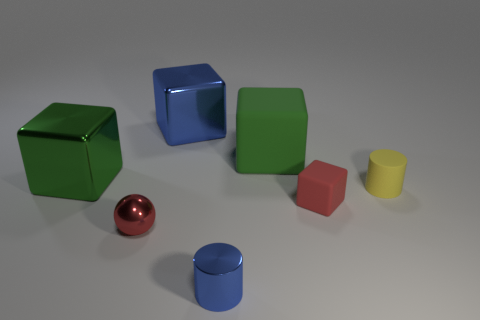There is a small cylinder on the right side of the matte thing behind the large shiny block that is to the left of the big blue block; what is it made of?
Ensure brevity in your answer.  Rubber. Does the shiny cylinder have the same color as the big metal object that is behind the green shiny thing?
Your answer should be very brief. Yes. What number of things are either matte things to the right of the green matte cube or metal things behind the tiny red matte cube?
Your answer should be compact. 4. The blue thing behind the metal block that is on the left side of the red metallic ball is what shape?
Make the answer very short. Cube. Is there a cylinder made of the same material as the red ball?
Your answer should be compact. Yes. The tiny object that is the same shape as the large blue object is what color?
Keep it short and to the point. Red. Are there fewer big green metallic cubes right of the blue cylinder than rubber blocks behind the small yellow matte cylinder?
Offer a terse response. Yes. How many other things are there of the same shape as the large matte thing?
Your answer should be very brief. 3. Are there fewer tiny red shiny objects in front of the small metal cylinder than green shiny spheres?
Your answer should be compact. No. There is a small cylinder to the right of the blue cylinder; what material is it?
Your response must be concise. Rubber. 